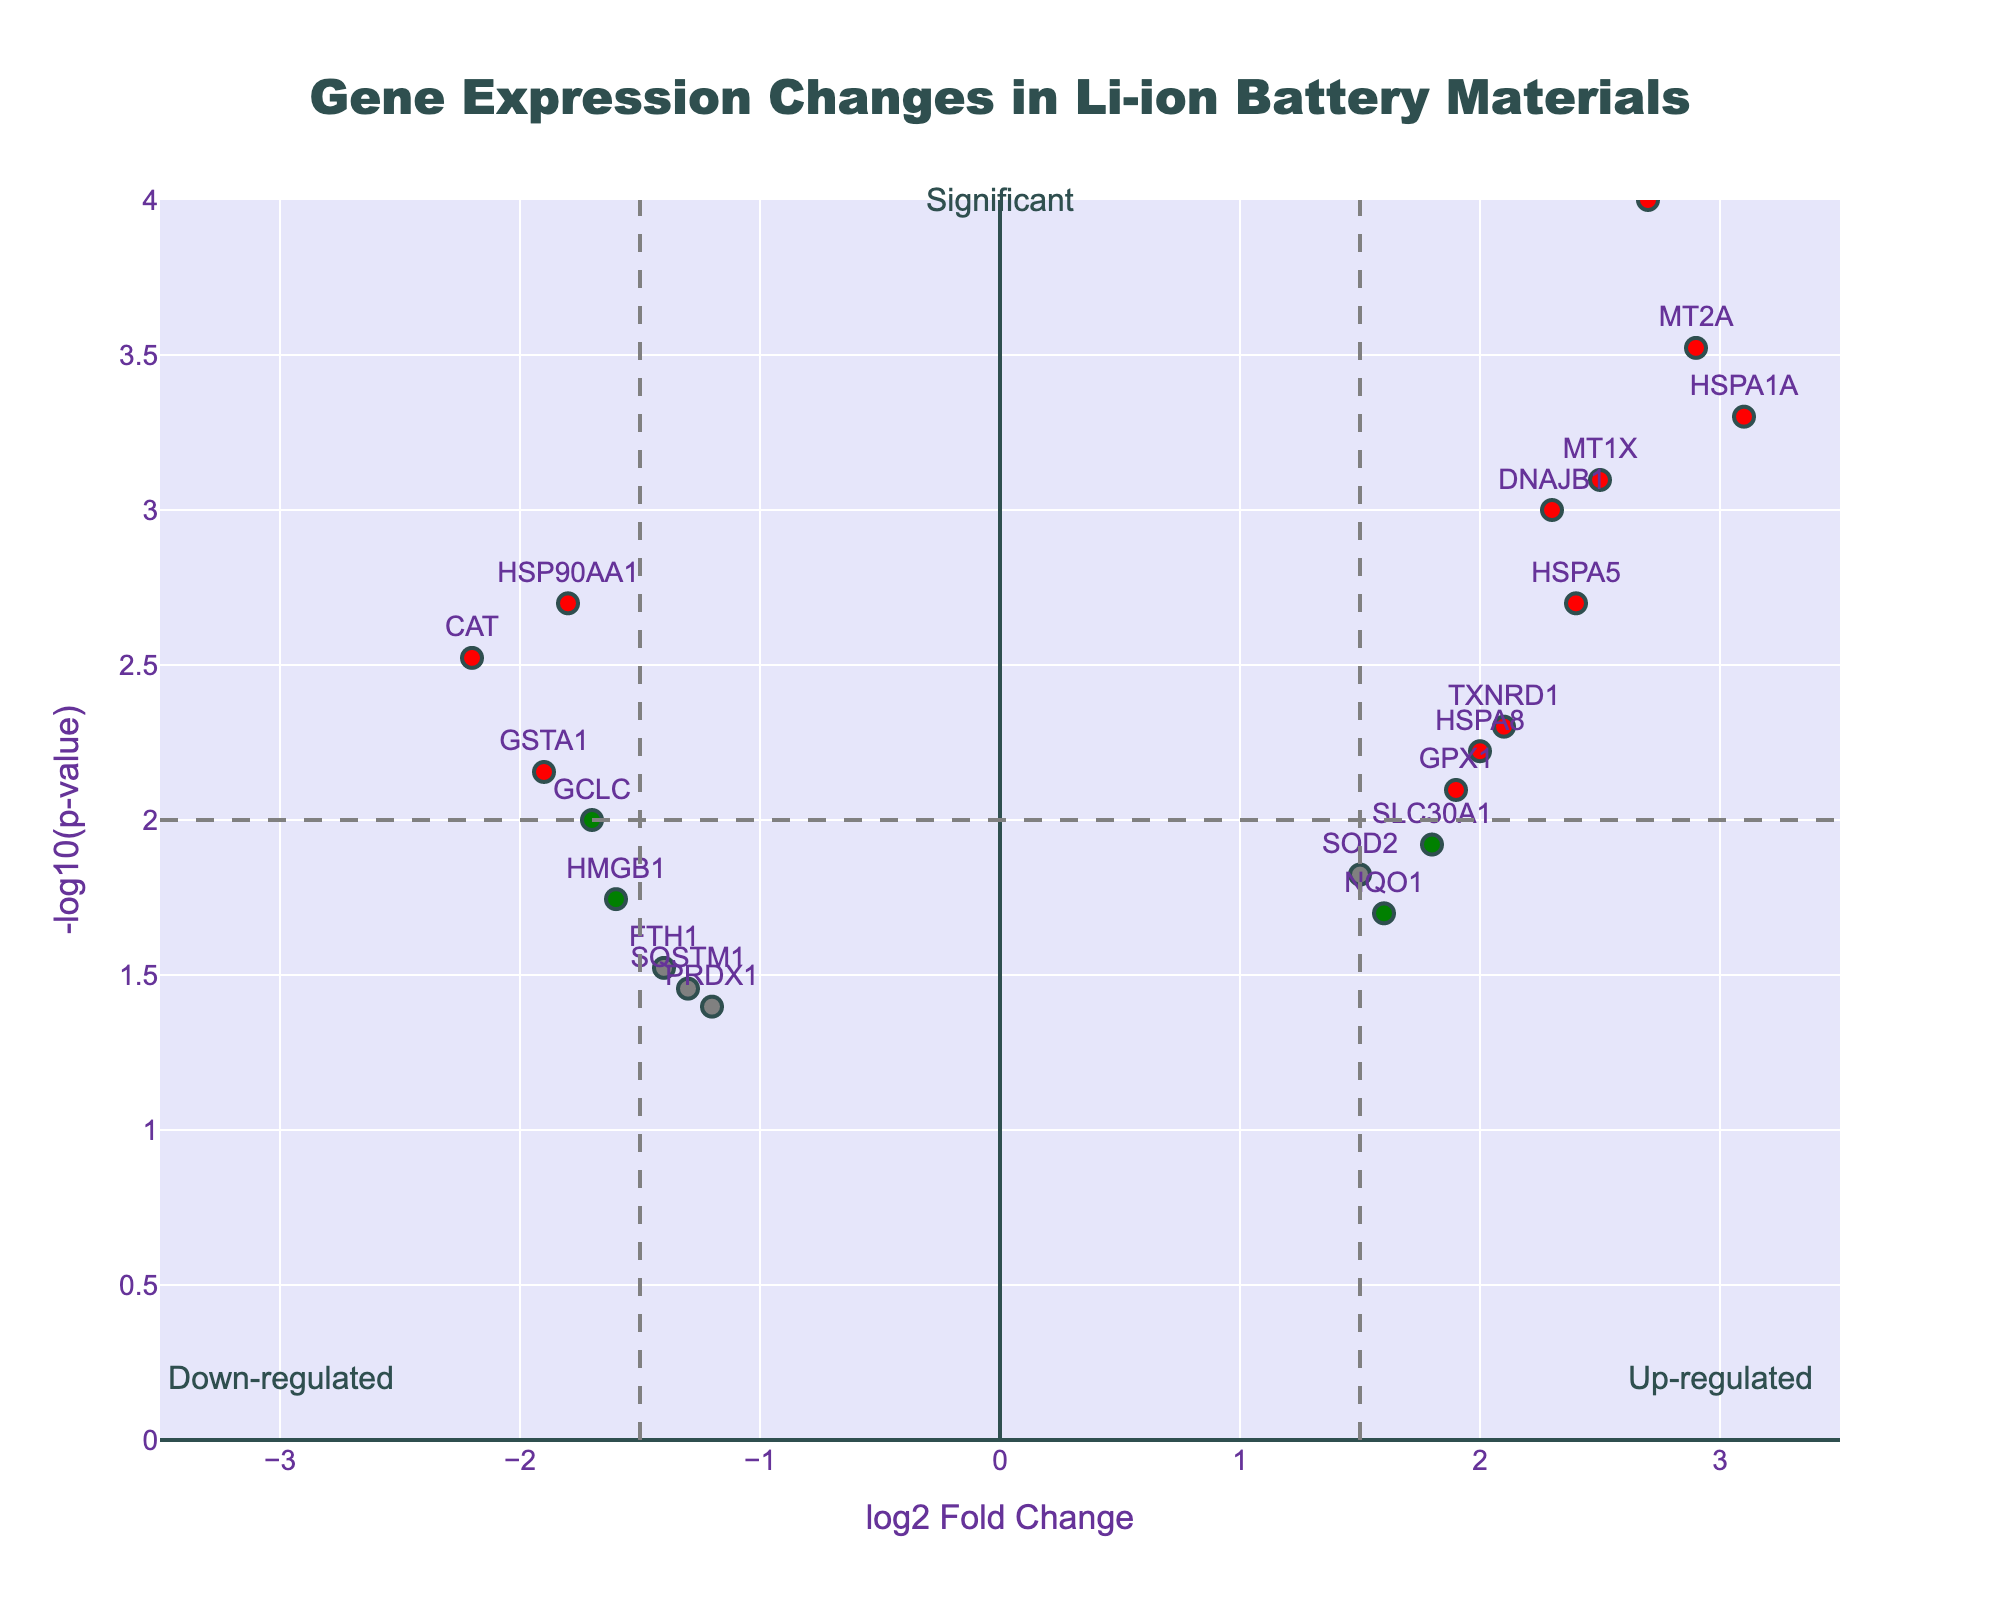What is the title of the Volcano Plot? The title of the Volcano Plot is typically located at the top center of the figure. In this case, it reads "Gene Expression Changes in Li-ion Battery Materials."
Answer: Gene Expression Changes in Li-ion Battery Materials How many genes are significantly up-regulated? Significantly up-regulated genes are those in the top right quadrant of the volcano plot with both high log2 fold change (greater than 1.5) and low p-value (less than 0.01). These points are colored red. Count the red points to determine the number of significantly up-regulated genes.
Answer: 8 Which gene shows the highest level of up-regulation? To find the gene with the highest level of up-regulation, look for the gene with the highest log2 fold change on the positive side of the x-axis. Check the gene label for the highest point on the right-side.
Answer: HSPA1A What is the x-axis label on the plot? The x-axis label is typically close to the bottom of the figure, indicating the measure represented along the x-axis. In this case, it reads "log2 Fold Change."
Answer: log2 Fold Change How would you determine the threshold for statistical significance on the p-value? The threshold for statistical significance on the p-value is indicated by the horizontal dashed line. This line represents -log10(0.01) as the threshold value. Calculate -log10(0.01) to confirm.
Answer: 2 Which genes are colored blue, and what does this color signify about their expression levels? Genes colored blue are those that have a low p-value (less than 0.01) but a log2 fold change within the threshold range (between -1.5 and 1.5). Identify the genes with blue coloring from the plot.
Answer: SOD2, NQO1, SLC30A1 How is the x-axis range determined in the plot? The x-axis range is set to cover a specific interval to include all data points and provide clarity. Here, it spans from -3.5 to 3.5, ensuring all points are visible and well-distributed along the axis.
Answer: -3.5 to 3.5 Which gene has the lowest p-value, and what is its significance level on the plot? To find the gene with the lowest p-value, look for the highest point on the y-axis, which corresponds to the smallest p-value after -log10 transformation. This gene is high on the plot.
Answer: HMOX1 Comparing genes HSPA1A and CAT, which one has a more significant up-regulation? Compare the log2 fold change and -log10(p-value) for both genes. HSPA1A is higher on the y-axis and further to the right on the x-axis than CAT, indicating a more significant up-regulation.
Answer: HSPA1A 